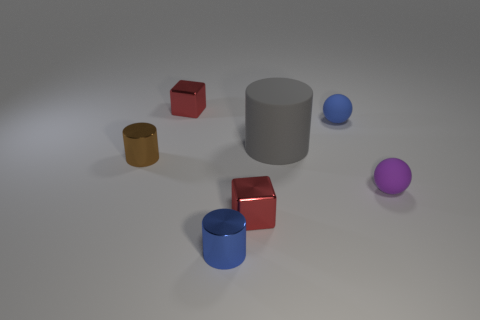Subtract all tiny cylinders. How many cylinders are left? 1 Add 2 purple balls. How many objects exist? 9 Subtract all blocks. How many objects are left? 5 Subtract all gray cylinders. How many cylinders are left? 2 Subtract 1 cubes. How many cubes are left? 1 Subtract all blue cylinders. How many blue balls are left? 1 Subtract all big red matte blocks. Subtract all small purple objects. How many objects are left? 6 Add 5 tiny metallic cubes. How many tiny metallic cubes are left? 7 Add 3 blue matte things. How many blue matte things exist? 4 Subtract 0 yellow blocks. How many objects are left? 7 